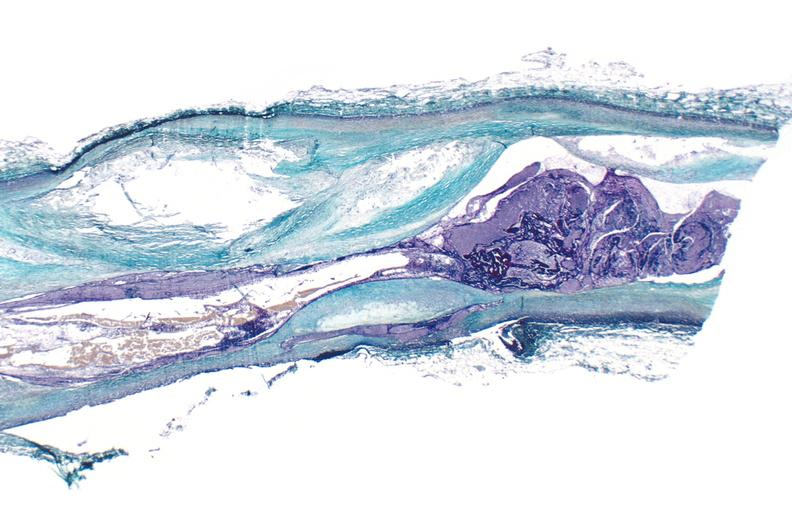s urinary present?
Answer the question using a single word or phrase. Yes 